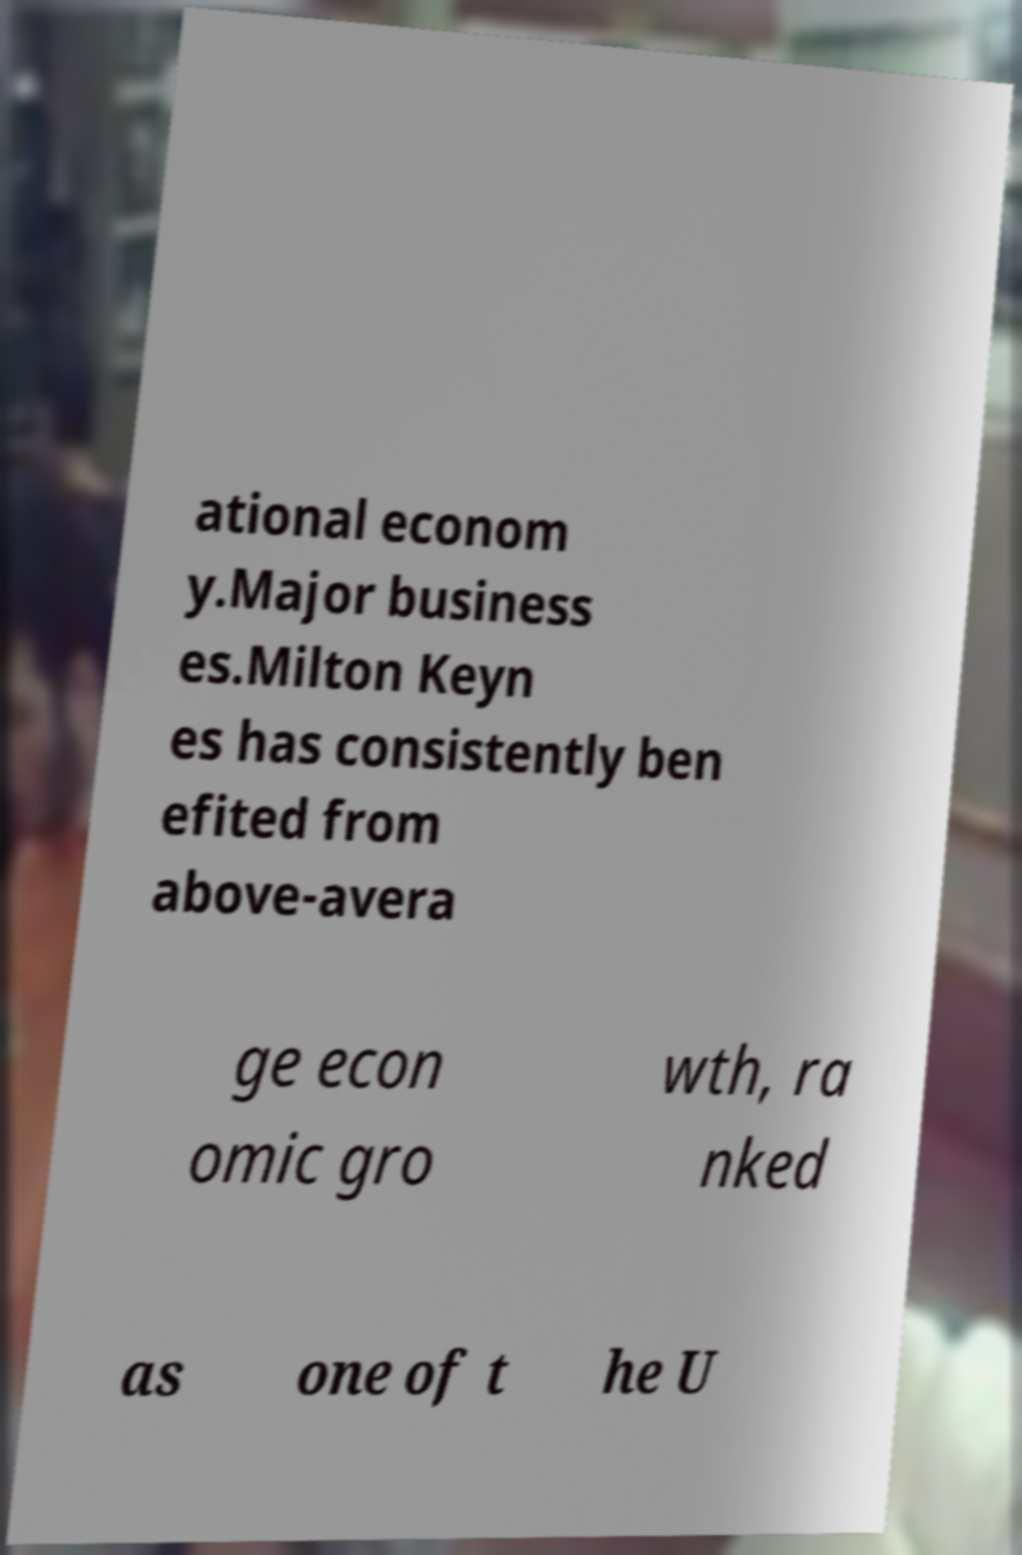Could you extract and type out the text from this image? ational econom y.Major business es.Milton Keyn es has consistently ben efited from above-avera ge econ omic gro wth, ra nked as one of t he U 